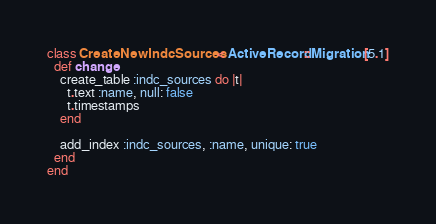Convert code to text. <code><loc_0><loc_0><loc_500><loc_500><_Ruby_>class CreateNewIndcSources < ActiveRecord::Migration[5.1]
  def change
    create_table :indc_sources do |t|
      t.text :name, null: false
      t.timestamps
    end

    add_index :indc_sources, :name, unique: true
  end
end
</code> 